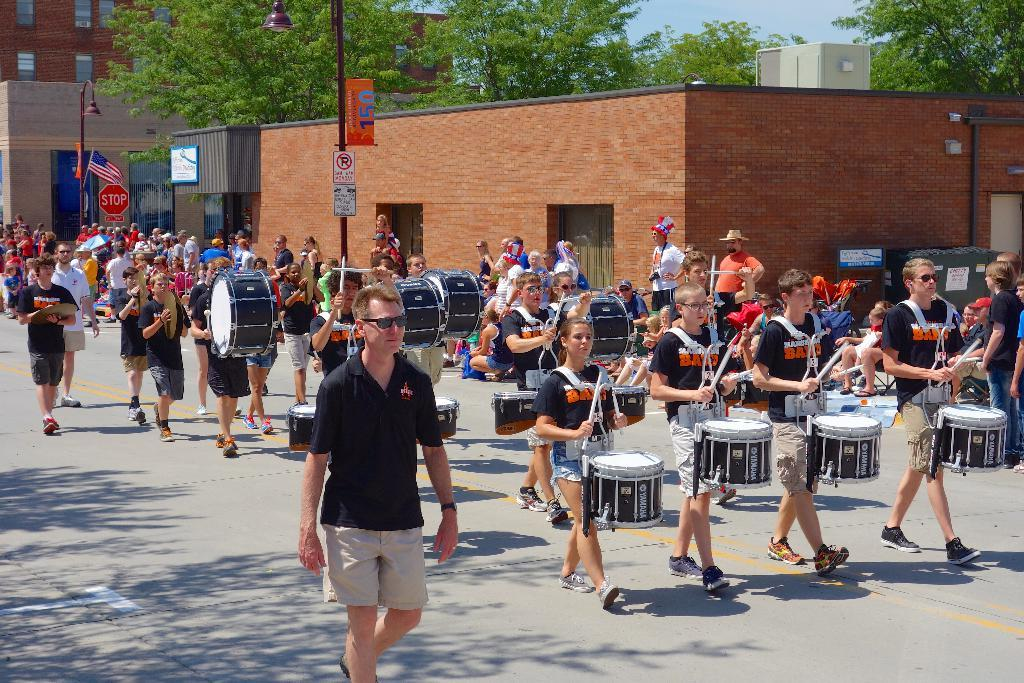What are the people in the image doing? There are people walking on the road, and some people are playing drums. What can be seen in the background of the image? There are trees and buildings visible in the image. Can you tell me how many people are trying to control the trees in the image? There is no indication in the image that anyone is trying to control the trees, and therefore no such activity can be observed. 